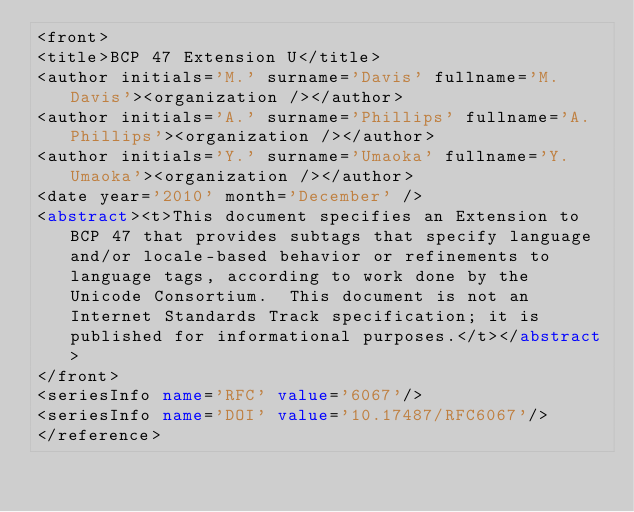Convert code to text. <code><loc_0><loc_0><loc_500><loc_500><_XML_><front>
<title>BCP 47 Extension U</title>
<author initials='M.' surname='Davis' fullname='M. Davis'><organization /></author>
<author initials='A.' surname='Phillips' fullname='A. Phillips'><organization /></author>
<author initials='Y.' surname='Umaoka' fullname='Y. Umaoka'><organization /></author>
<date year='2010' month='December' />
<abstract><t>This document specifies an Extension to BCP 47 that provides subtags that specify language and/or locale-based behavior or refinements to language tags, according to work done by the Unicode Consortium.  This document is not an Internet Standards Track specification; it is published for informational purposes.</t></abstract>
</front>
<seriesInfo name='RFC' value='6067'/>
<seriesInfo name='DOI' value='10.17487/RFC6067'/>
</reference>
</code> 